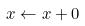<formula> <loc_0><loc_0><loc_500><loc_500>x \leftarrow x + 0</formula> 